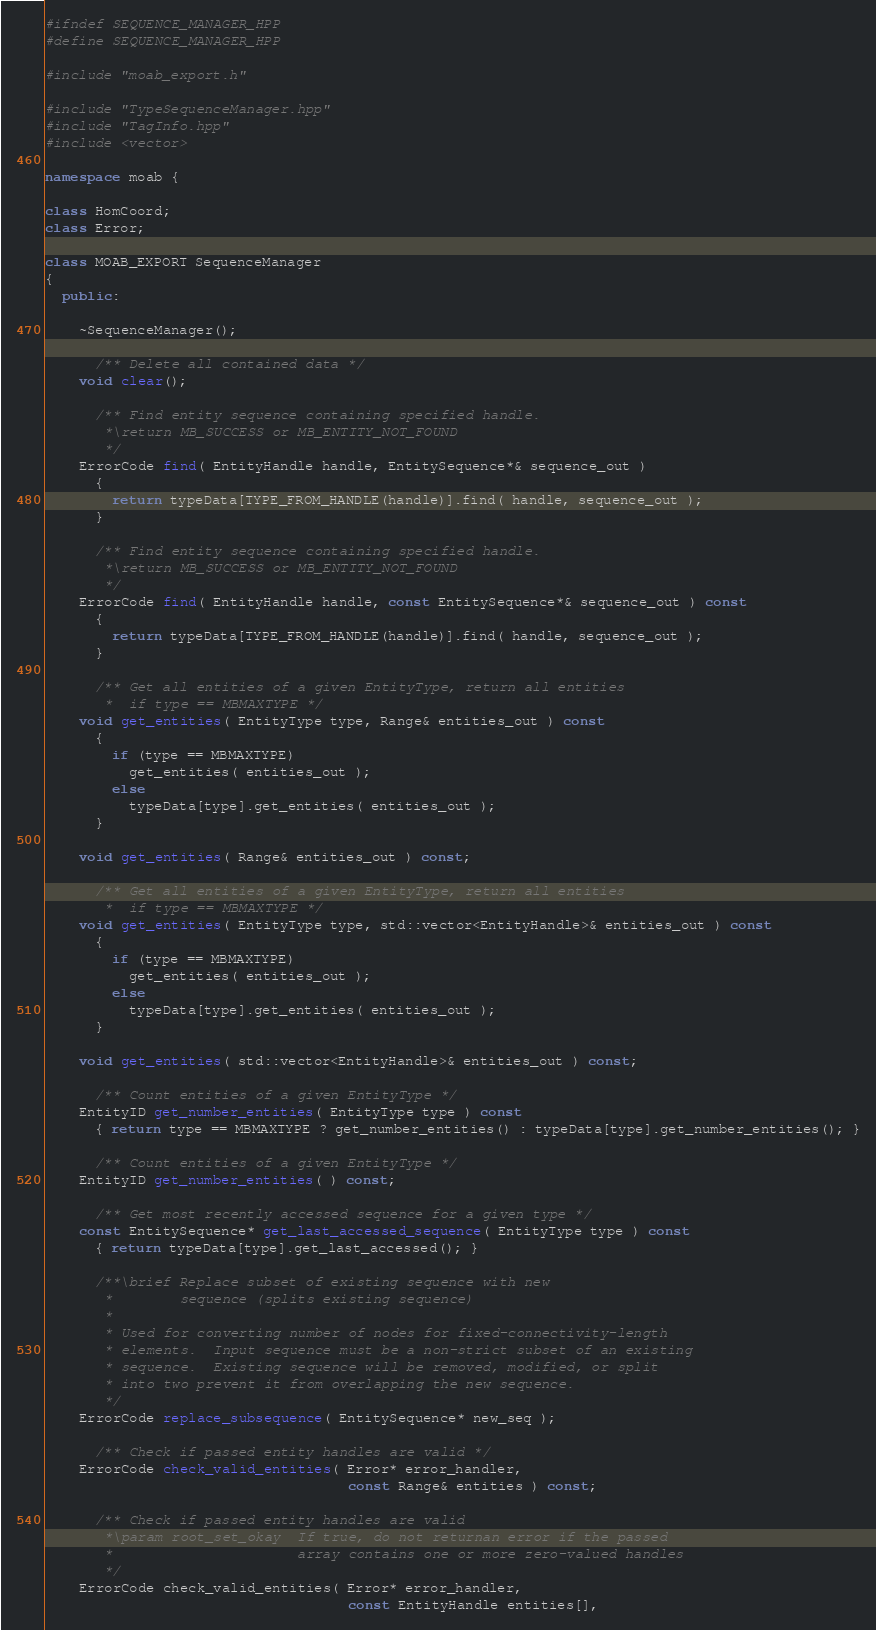<code> <loc_0><loc_0><loc_500><loc_500><_C++_>#ifndef SEQUENCE_MANAGER_HPP
#define SEQUENCE_MANAGER_HPP

#include "moab_export.h"

#include "TypeSequenceManager.hpp"
#include "TagInfo.hpp"
#include <vector>

namespace moab {

class HomCoord;
class Error;

class MOAB_EXPORT SequenceManager 
{
  public:
    
    ~SequenceManager();
    
      /** Delete all contained data */
    void clear();
    
      /** Find entity sequence containing specified handle.
       *\return MB_SUCCESS or MB_ENTITY_NOT_FOUND
       */
    ErrorCode find( EntityHandle handle, EntitySequence*& sequence_out )
      { 
        return typeData[TYPE_FROM_HANDLE(handle)].find( handle, sequence_out );
      }
    
      /** Find entity sequence containing specified handle.
       *\return MB_SUCCESS or MB_ENTITY_NOT_FOUND
       */
    ErrorCode find( EntityHandle handle, const EntitySequence*& sequence_out ) const
      { 
        return typeData[TYPE_FROM_HANDLE(handle)].find( handle, sequence_out );
      }
    
      /** Get all entities of a given EntityType, return all entities
       *  if type == MBMAXTYPE */
    void get_entities( EntityType type, Range& entities_out ) const
      { 
        if (type == MBMAXTYPE)
          get_entities( entities_out );
        else
          typeData[type].get_entities( entities_out ); 
      }

    void get_entities( Range& entities_out ) const;
    
      /** Get all entities of a given EntityType, return all entities
       *  if type == MBMAXTYPE */
    void get_entities( EntityType type, std::vector<EntityHandle>& entities_out ) const
      { 
        if (type == MBMAXTYPE)
          get_entities( entities_out );
        else
          typeData[type].get_entities( entities_out ); 
      }
    
    void get_entities( std::vector<EntityHandle>& entities_out ) const;
    
      /** Count entities of a given EntityType */
    EntityID get_number_entities( EntityType type ) const
      { return type == MBMAXTYPE ? get_number_entities() : typeData[type].get_number_entities(); }
    
      /** Count entities of a given EntityType */
    EntityID get_number_entities( ) const;
      
      /** Get most recently accessed sequence for a given type */
    const EntitySequence* get_last_accessed_sequence( EntityType type ) const
      { return typeData[type].get_last_accessed(); }
    
      /**\brief Replace subset of existing sequence with new 
       *        sequence (splits existing sequence)
       *
       * Used for converting number of nodes for fixed-connectivity-length
       * elements.  Input sequence must be a non-strict subset of an existing
       * sequence.  Existing sequence will be removed, modified, or split
       * into two prevent it from overlapping the new sequence.
       */
    ErrorCode replace_subsequence( EntitySequence* new_seq );
    
      /** Check if passed entity handles are valid */
    ErrorCode check_valid_entities( Error* error_handler, 
                                    const Range& entities ) const;
    
      /** Check if passed entity handles are valid 
       *\param root_set_okay  If true, do not returnan error if the passed
       *                      array contains one or more zero-valued handles 
       */
    ErrorCode check_valid_entities( Error* error_handler,
                                    const EntityHandle entities[],</code> 